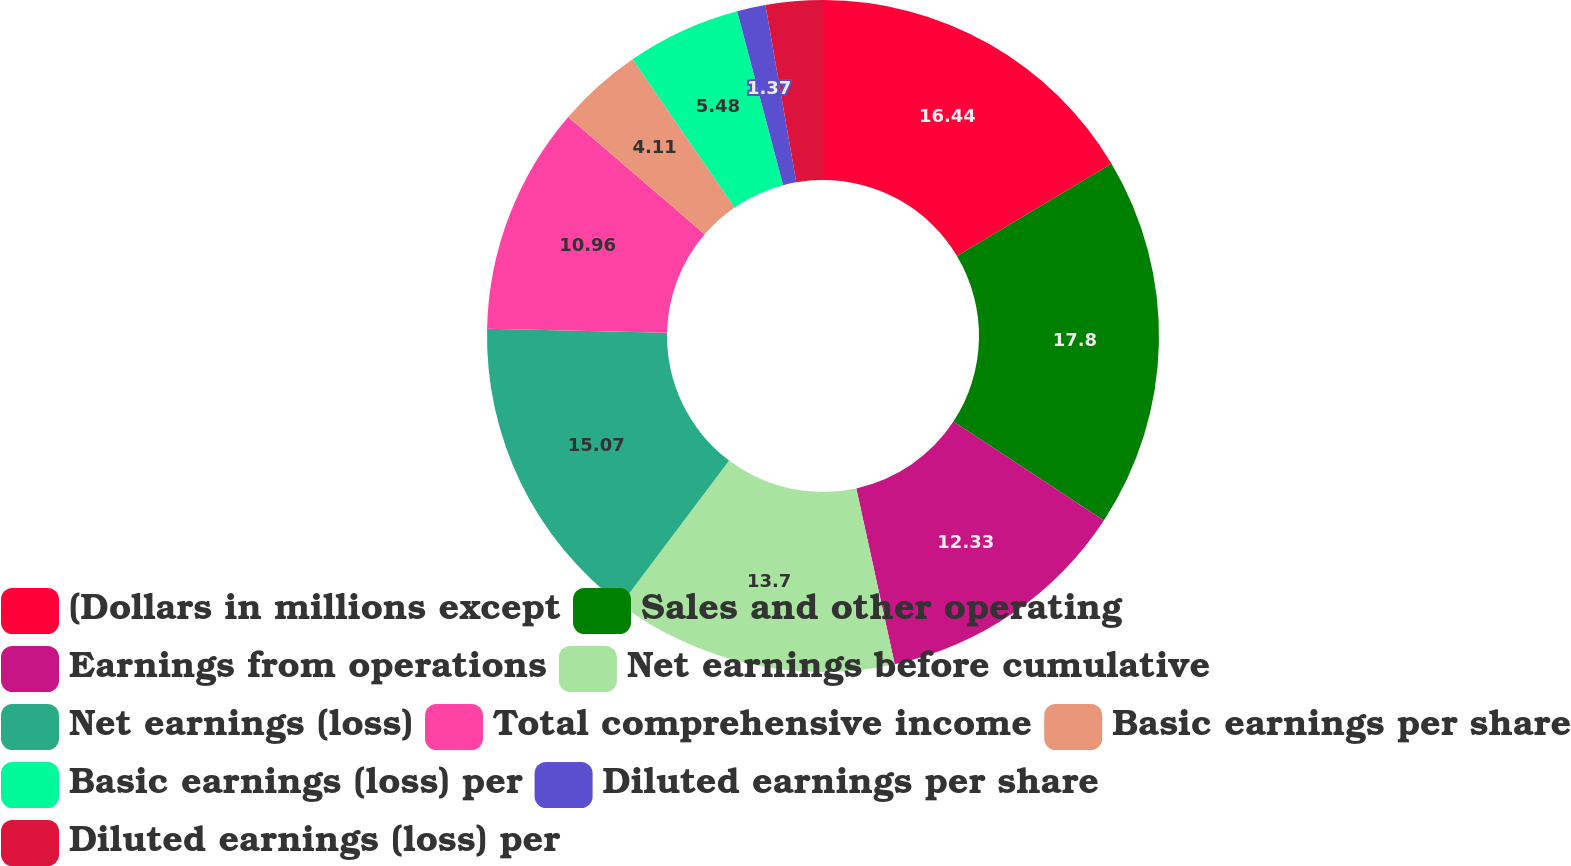Convert chart. <chart><loc_0><loc_0><loc_500><loc_500><pie_chart><fcel>(Dollars in millions except<fcel>Sales and other operating<fcel>Earnings from operations<fcel>Net earnings before cumulative<fcel>Net earnings (loss)<fcel>Total comprehensive income<fcel>Basic earnings per share<fcel>Basic earnings (loss) per<fcel>Diluted earnings per share<fcel>Diluted earnings (loss) per<nl><fcel>16.44%<fcel>17.81%<fcel>12.33%<fcel>13.7%<fcel>15.07%<fcel>10.96%<fcel>4.11%<fcel>5.48%<fcel>1.37%<fcel>2.74%<nl></chart> 